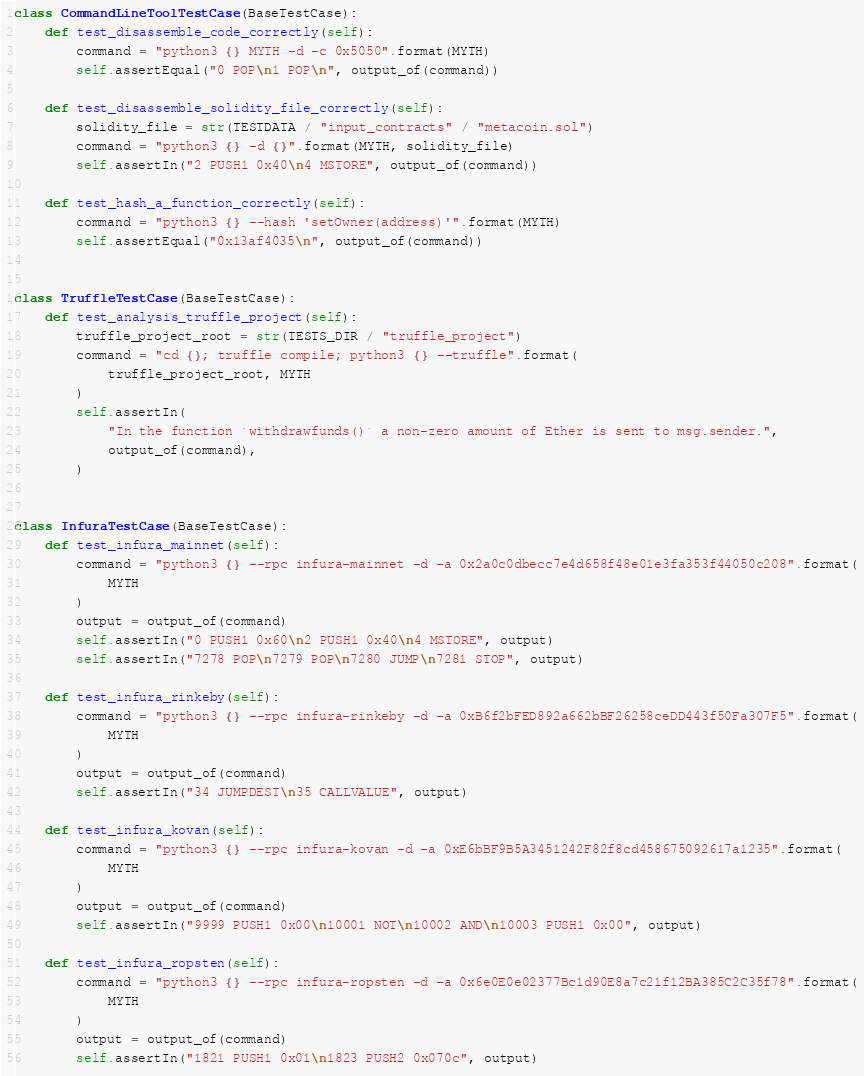<code> <loc_0><loc_0><loc_500><loc_500><_Python_>class CommandLineToolTestCase(BaseTestCase):
    def test_disassemble_code_correctly(self):
        command = "python3 {} MYTH -d -c 0x5050".format(MYTH)
        self.assertEqual("0 POP\n1 POP\n", output_of(command))

    def test_disassemble_solidity_file_correctly(self):
        solidity_file = str(TESTDATA / "input_contracts" / "metacoin.sol")
        command = "python3 {} -d {}".format(MYTH, solidity_file)
        self.assertIn("2 PUSH1 0x40\n4 MSTORE", output_of(command))

    def test_hash_a_function_correctly(self):
        command = "python3 {} --hash 'setOwner(address)'".format(MYTH)
        self.assertEqual("0x13af4035\n", output_of(command))


class TruffleTestCase(BaseTestCase):
    def test_analysis_truffle_project(self):
        truffle_project_root = str(TESTS_DIR / "truffle_project")
        command = "cd {}; truffle compile; python3 {} --truffle".format(
            truffle_project_root, MYTH
        )
        self.assertIn(
            "In the function `withdrawfunds()` a non-zero amount of Ether is sent to msg.sender.",
            output_of(command),
        )


class InfuraTestCase(BaseTestCase):
    def test_infura_mainnet(self):
        command = "python3 {} --rpc infura-mainnet -d -a 0x2a0c0dbecc7e4d658f48e01e3fa353f44050c208".format(
            MYTH
        )
        output = output_of(command)
        self.assertIn("0 PUSH1 0x60\n2 PUSH1 0x40\n4 MSTORE", output)
        self.assertIn("7278 POP\n7279 POP\n7280 JUMP\n7281 STOP", output)

    def test_infura_rinkeby(self):
        command = "python3 {} --rpc infura-rinkeby -d -a 0xB6f2bFED892a662bBF26258ceDD443f50Fa307F5".format(
            MYTH
        )
        output = output_of(command)
        self.assertIn("34 JUMPDEST\n35 CALLVALUE", output)

    def test_infura_kovan(self):
        command = "python3 {} --rpc infura-kovan -d -a 0xE6bBF9B5A3451242F82f8cd458675092617a1235".format(
            MYTH
        )
        output = output_of(command)
        self.assertIn("9999 PUSH1 0x00\n10001 NOT\n10002 AND\n10003 PUSH1 0x00", output)

    def test_infura_ropsten(self):
        command = "python3 {} --rpc infura-ropsten -d -a 0x6e0E0e02377Bc1d90E8a7c21f12BA385C2C35f78".format(
            MYTH
        )
        output = output_of(command)
        self.assertIn("1821 PUSH1 0x01\n1823 PUSH2 0x070c", output)
</code> 